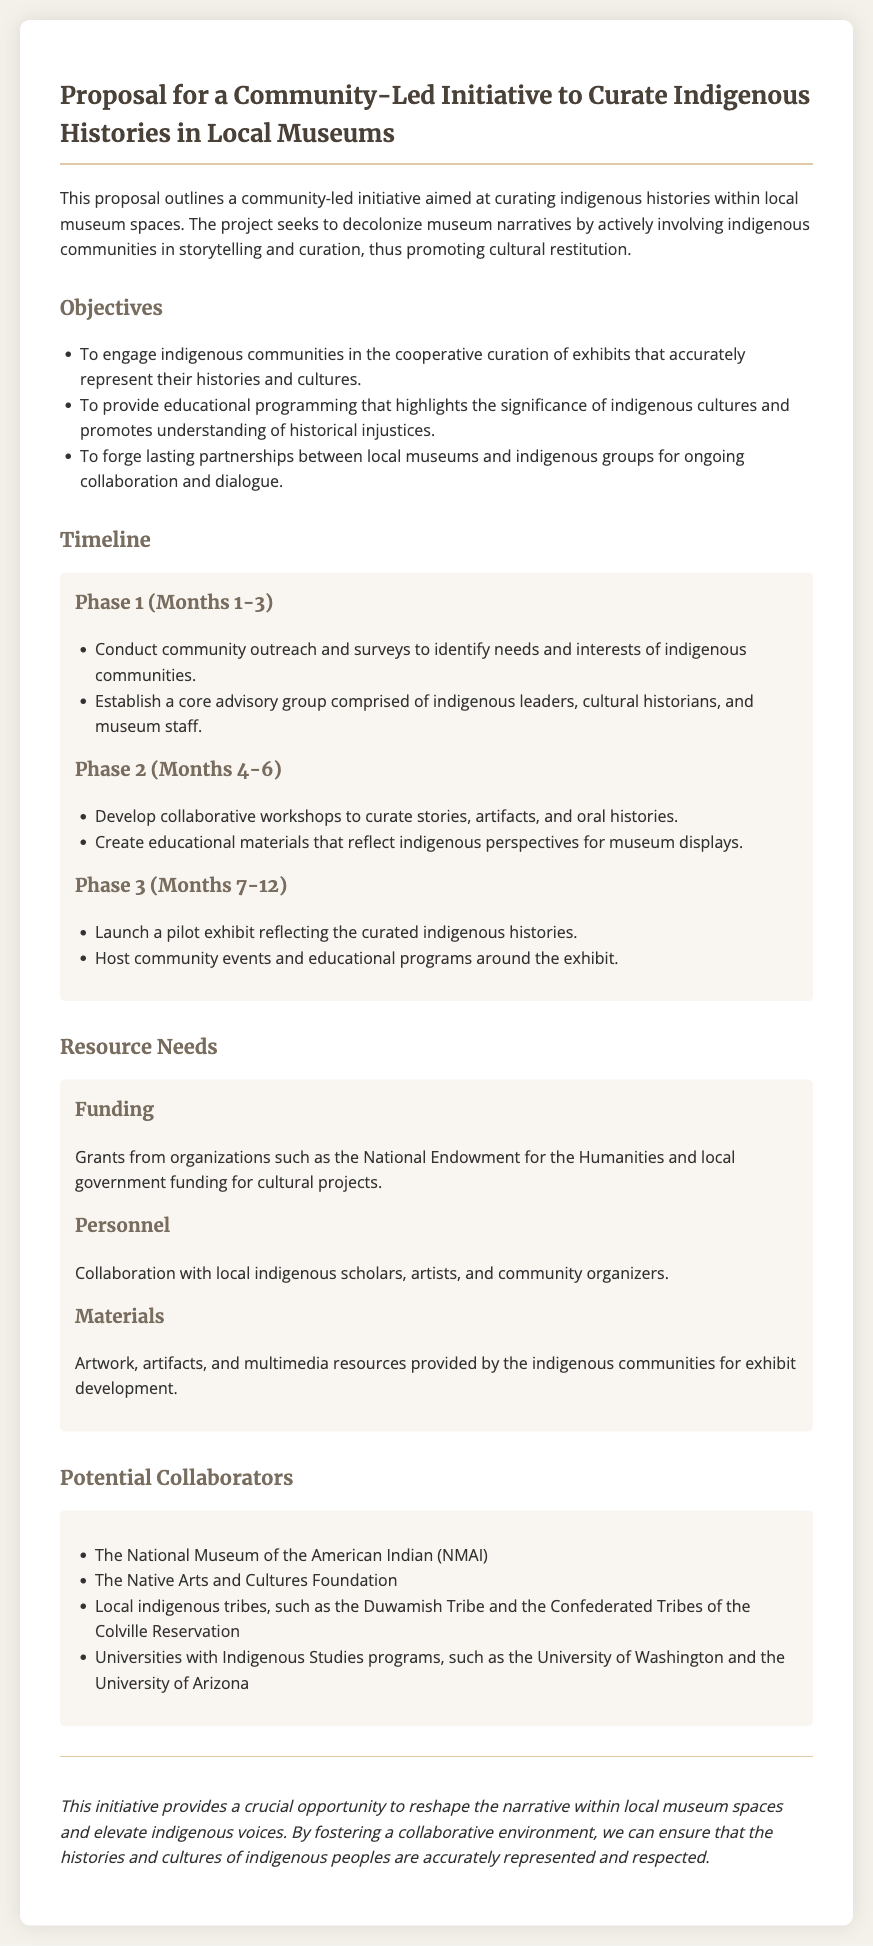What is the title of the proposal? The title provides the main focus of the document and is clearly stated at the top.
Answer: Proposal for a Community-Led Initiative to Curate Indigenous Histories in Local Museums What is the duration of Phase 2? The document specifies the timeline for each phase, including the duration of Phase 2.
Answer: Months 4-6 Which organization is listed as a potential collaborator? The document lists several potential collaborators, highlighting partnerships for the initiative.
Answer: The National Museum of the American Indian (NMAI) What are the resource needs for funding? The document outlines various types of resource needs, explicitly stating those related to funding.
Answer: Grants from organizations such as the National Endowment for the Humanities and local government funding for cultural projects What is one of the objectives of the initiative? The objectives section lists several goals of the initiative, reflecting its purpose.
Answer: To engage indigenous communities in the cooperative curation of exhibits that accurately represent their histories and cultures What is the last phase of the timeline? The timeline provides a sequence of activities planned for the initiative, indicating the last phase.
Answer: Phase 3 (Months 7-12) What types of materials are needed for the initiative? The document specifies the types of materials that will be involved in the initiative, indicating their importance.
Answer: Artwork, artifacts, and multimedia resources provided by the indigenous communities for exhibit development How many phases are outlined in the timeline? The document provides clear sections for each phase, helping to quantify the overall structure of the timeline.
Answer: Three phases 